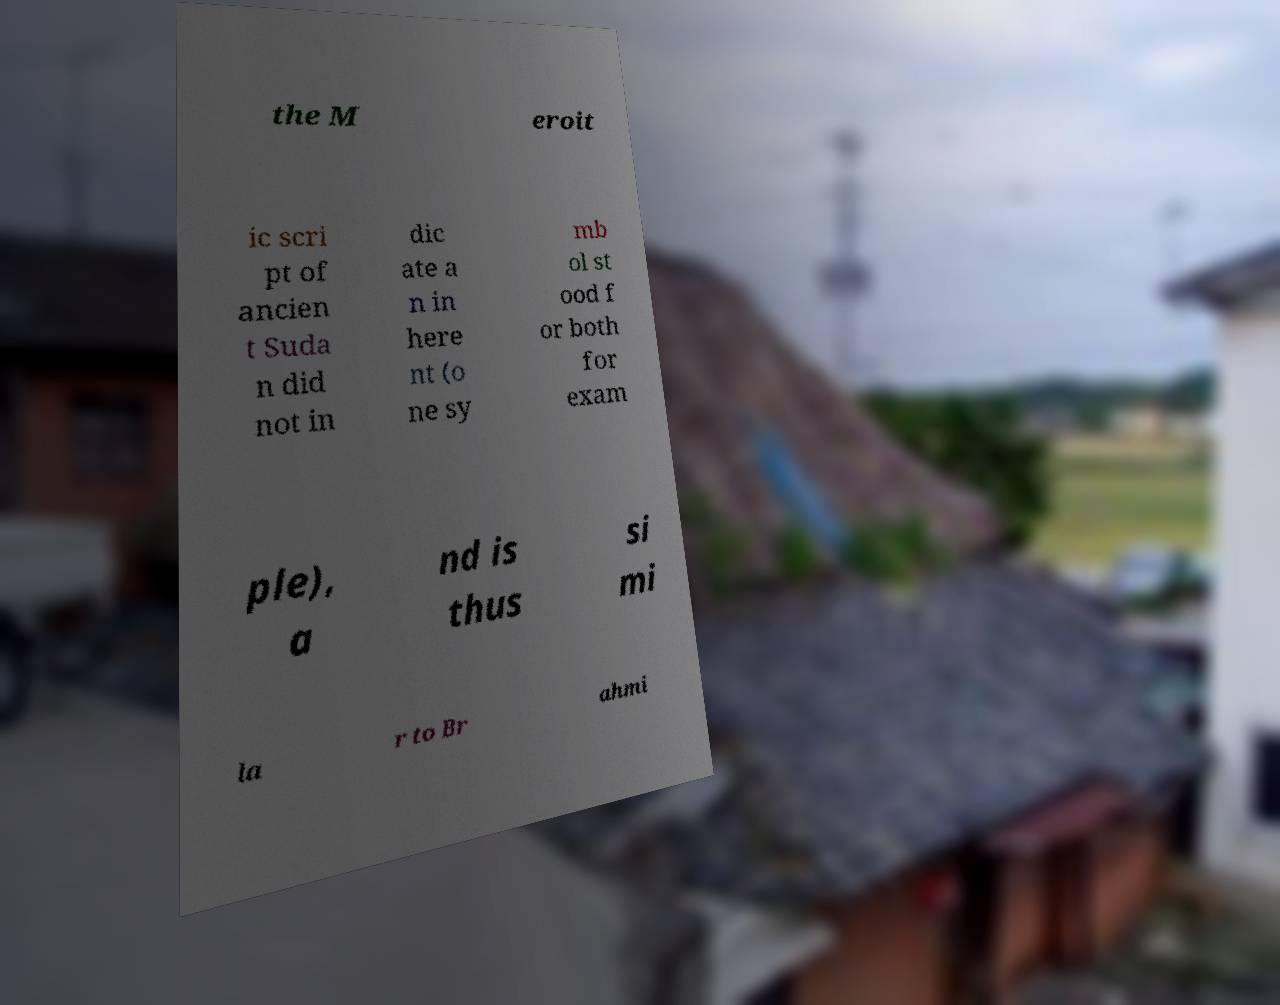Please identify and transcribe the text found in this image. the M eroit ic scri pt of ancien t Suda n did not in dic ate a n in here nt (o ne sy mb ol st ood f or both for exam ple), a nd is thus si mi la r to Br ahmi 